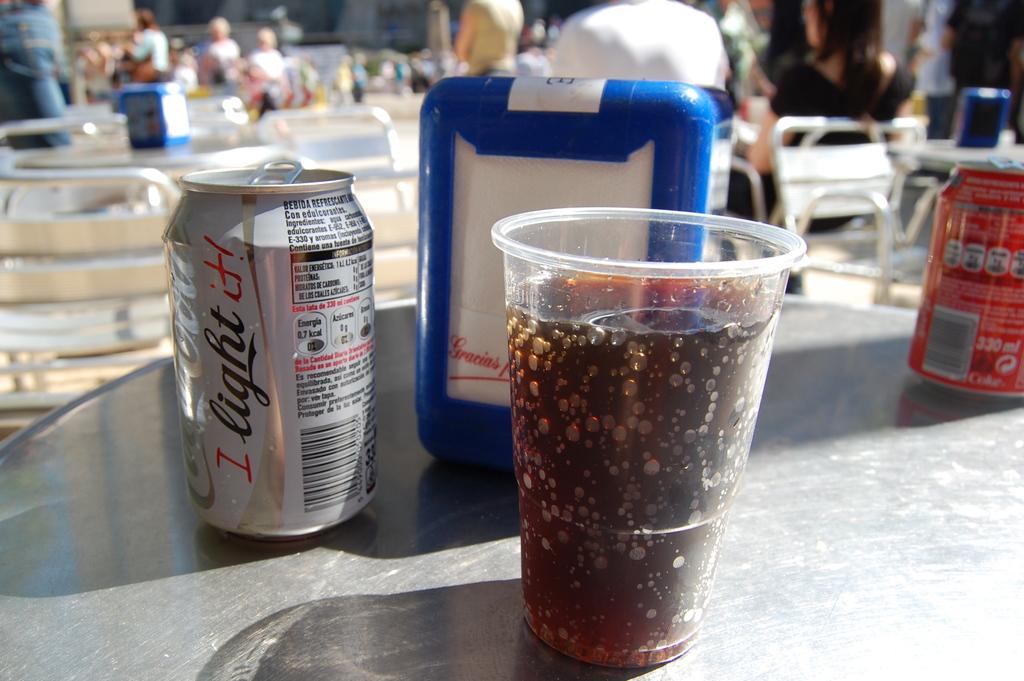What brand of soda is this?
Provide a short and direct response. Coca cola. 